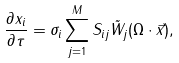<formula> <loc_0><loc_0><loc_500><loc_500>\frac { \partial x _ { i } } { \partial \tau } = \sigma _ { i } \sum _ { j = 1 } ^ { M } S _ { i j } \tilde { W } _ { j } ( \Omega \cdot \vec { x } ) ,</formula> 